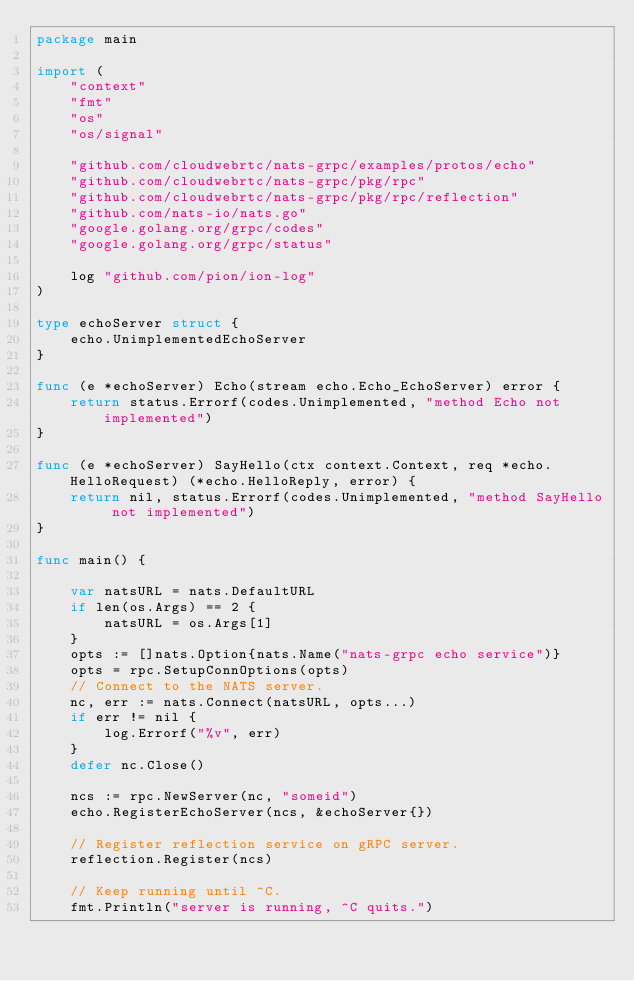Convert code to text. <code><loc_0><loc_0><loc_500><loc_500><_Go_>package main

import (
	"context"
	"fmt"
	"os"
	"os/signal"

	"github.com/cloudwebrtc/nats-grpc/examples/protos/echo"
	"github.com/cloudwebrtc/nats-grpc/pkg/rpc"
	"github.com/cloudwebrtc/nats-grpc/pkg/rpc/reflection"
	"github.com/nats-io/nats.go"
	"google.golang.org/grpc/codes"
	"google.golang.org/grpc/status"

	log "github.com/pion/ion-log"
)

type echoServer struct {
	echo.UnimplementedEchoServer
}

func (e *echoServer) Echo(stream echo.Echo_EchoServer) error {
	return status.Errorf(codes.Unimplemented, "method Echo not implemented")
}

func (e *echoServer) SayHello(ctx context.Context, req *echo.HelloRequest) (*echo.HelloReply, error) {
	return nil, status.Errorf(codes.Unimplemented, "method SayHello not implemented")
}

func main() {

	var natsURL = nats.DefaultURL
	if len(os.Args) == 2 {
		natsURL = os.Args[1]
	}
	opts := []nats.Option{nats.Name("nats-grpc echo service")}
	opts = rpc.SetupConnOptions(opts)
	// Connect to the NATS server.
	nc, err := nats.Connect(natsURL, opts...)
	if err != nil {
		log.Errorf("%v", err)
	}
	defer nc.Close()

	ncs := rpc.NewServer(nc, "someid")
	echo.RegisterEchoServer(ncs, &echoServer{})

	// Register reflection service on gRPC server.
	reflection.Register(ncs)

	// Keep running until ^C.
	fmt.Println("server is running, ^C quits.")</code> 